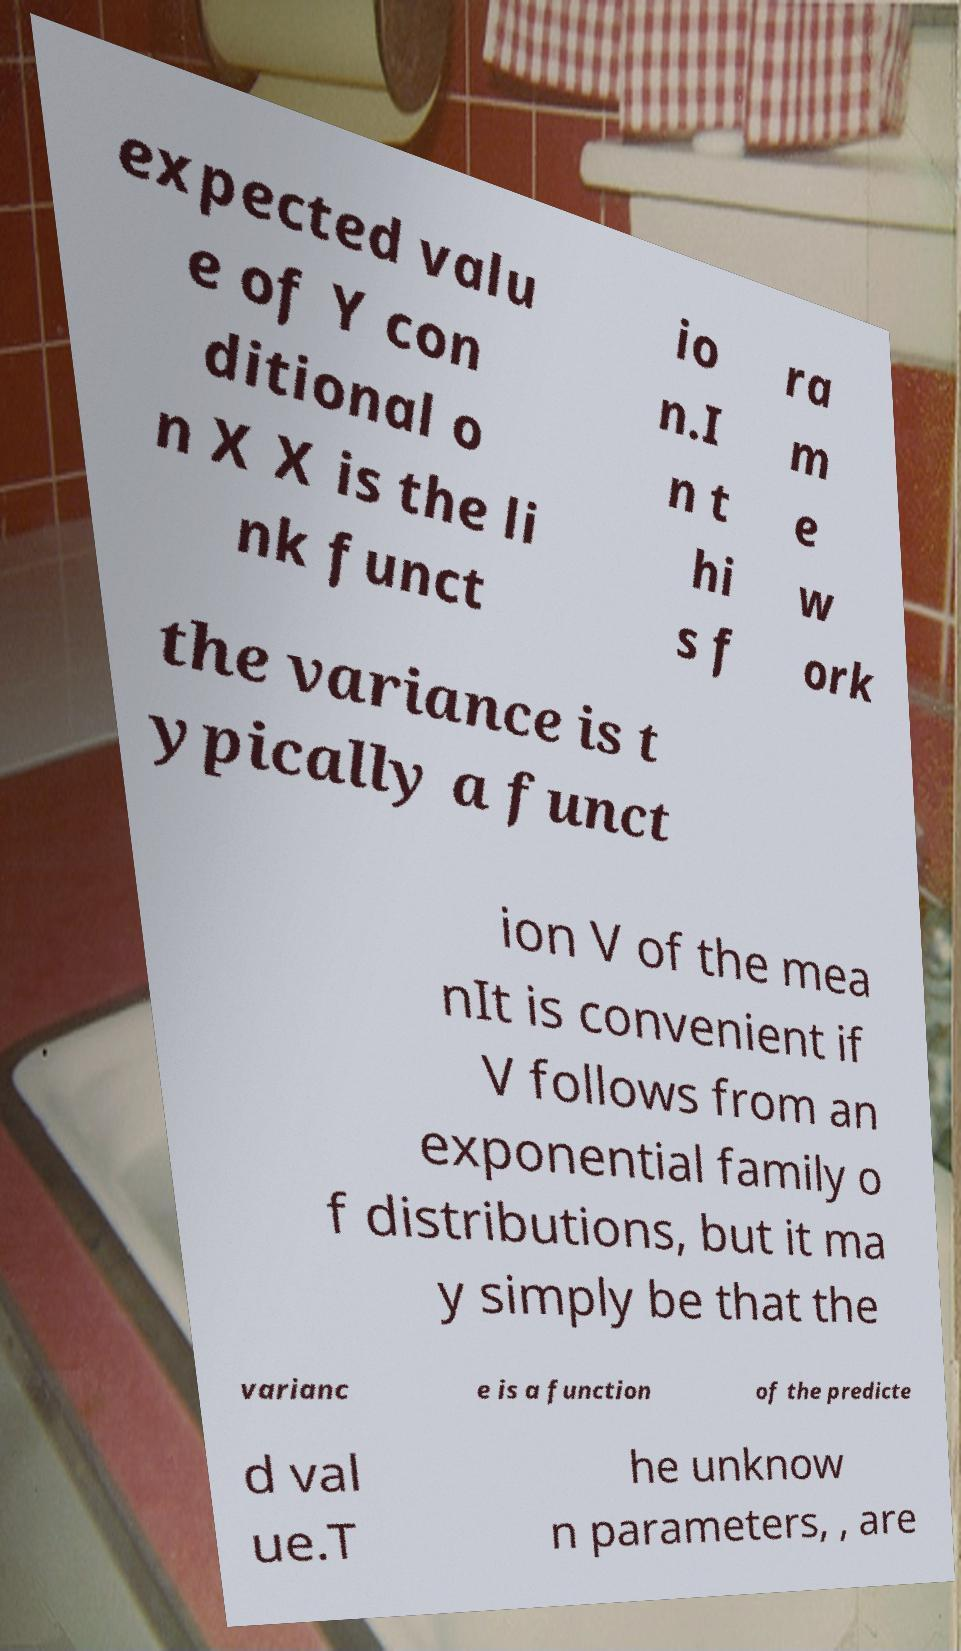Please identify and transcribe the text found in this image. expected valu e of Y con ditional o n X X is the li nk funct io n.I n t hi s f ra m e w ork the variance is t ypically a funct ion V of the mea nIt is convenient if V follows from an exponential family o f distributions, but it ma y simply be that the varianc e is a function of the predicte d val ue.T he unknow n parameters, , are 